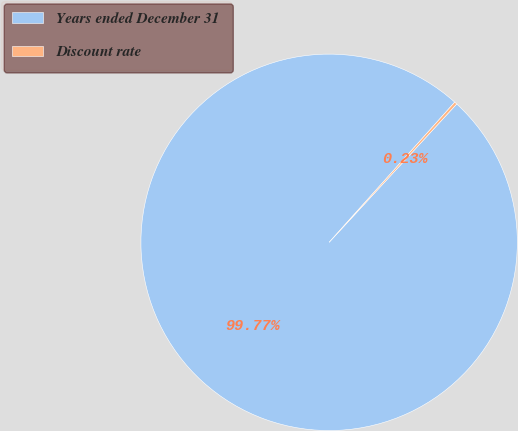Convert chart. <chart><loc_0><loc_0><loc_500><loc_500><pie_chart><fcel>Years ended December 31<fcel>Discount rate<nl><fcel>99.77%<fcel>0.23%<nl></chart> 